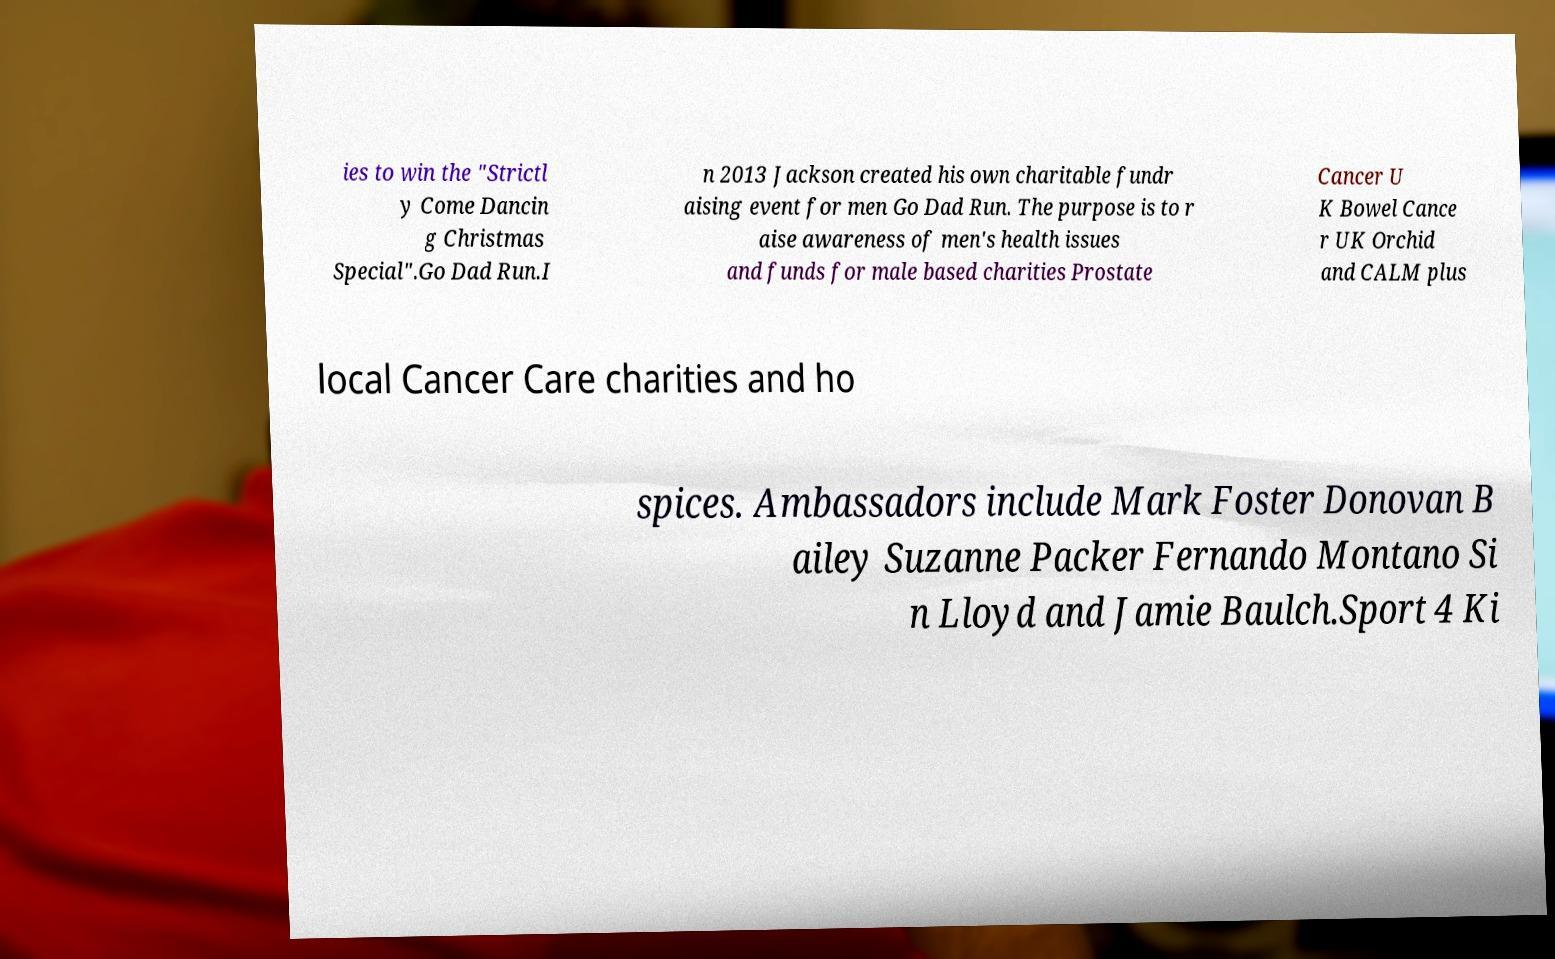Could you extract and type out the text from this image? ies to win the "Strictl y Come Dancin g Christmas Special".Go Dad Run.I n 2013 Jackson created his own charitable fundr aising event for men Go Dad Run. The purpose is to r aise awareness of men's health issues and funds for male based charities Prostate Cancer U K Bowel Cance r UK Orchid and CALM plus local Cancer Care charities and ho spices. Ambassadors include Mark Foster Donovan B ailey Suzanne Packer Fernando Montano Si n Lloyd and Jamie Baulch.Sport 4 Ki 